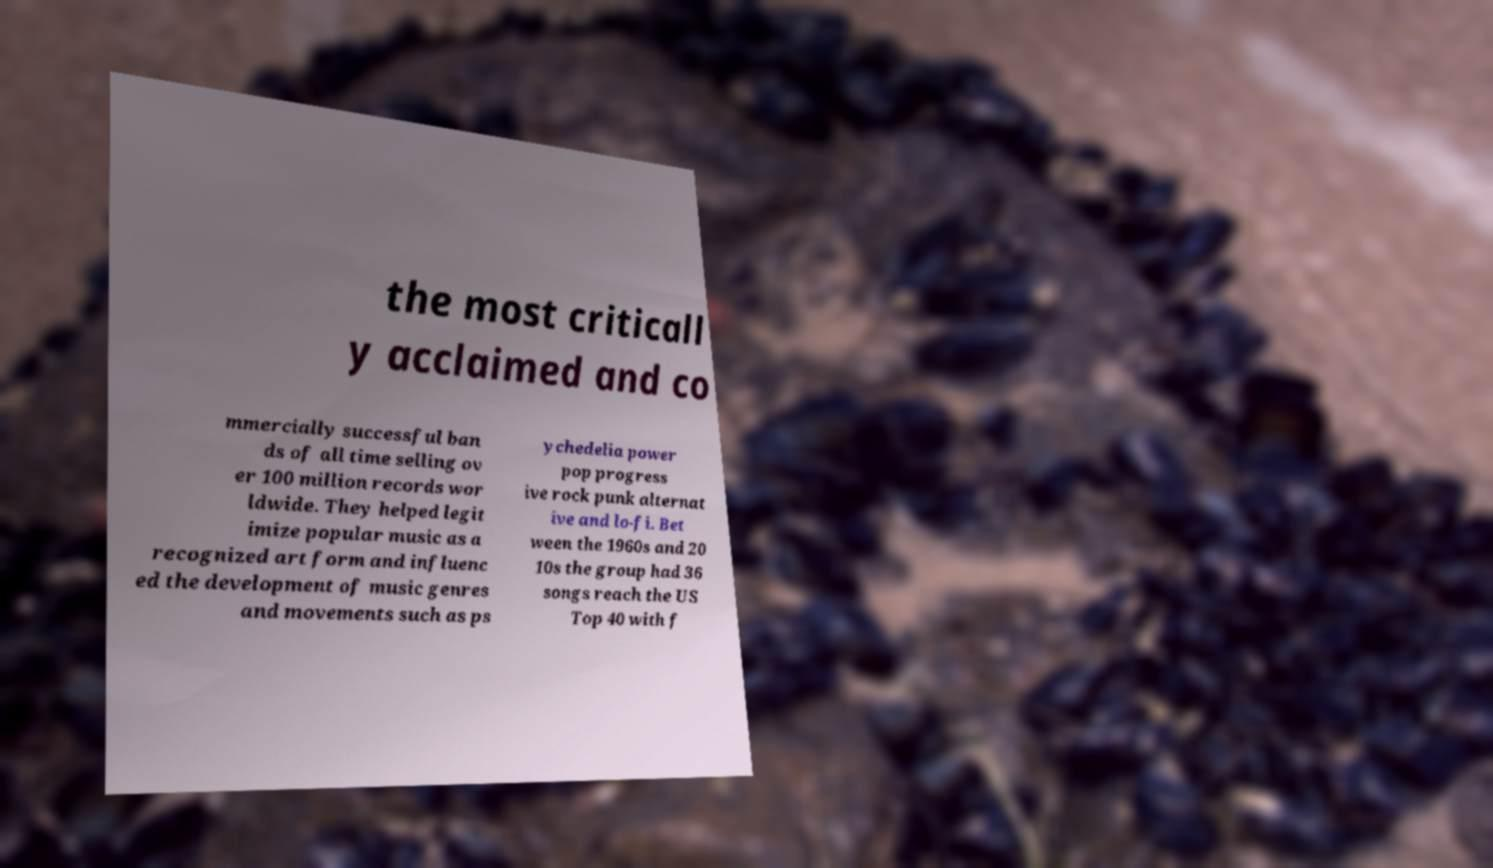Please read and relay the text visible in this image. What does it say? the most criticall y acclaimed and co mmercially successful ban ds of all time selling ov er 100 million records wor ldwide. They helped legit imize popular music as a recognized art form and influenc ed the development of music genres and movements such as ps ychedelia power pop progress ive rock punk alternat ive and lo-fi. Bet ween the 1960s and 20 10s the group had 36 songs reach the US Top 40 with f 